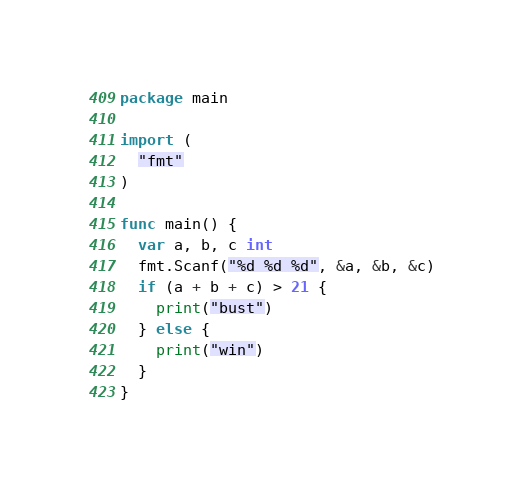Convert code to text. <code><loc_0><loc_0><loc_500><loc_500><_Go_>package main

import (
  "fmt"
)

func main() {
  var a, b, c int
  fmt.Scanf("%d %d %d", &a, &b, &c)
  if (a + b + c) > 21 {
    print("bust")
  } else {
    print("win")
  }
}</code> 